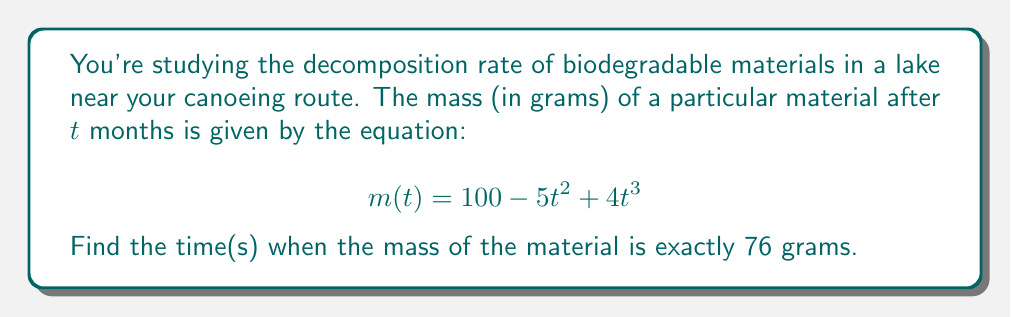Teach me how to tackle this problem. Let's approach this step-by-step:

1) We need to solve the equation:
   $$ 100 - 5t^2 + 4t^3 = 76 $$

2) Subtract 76 from both sides:
   $$ 24 - 5t^2 + 4t^3 = 0 $$

3) Rearrange to standard form:
   $$ 4t^3 - 5t^2 + 24 = 0 $$

4) This is a cubic equation. Let's try to factor it:
   $$ 4t^3 - 5t^2 + 24 = (4t - 3)(t^2 + \frac{3}{4}t - 8) $$

5) Now we can set each factor to zero and solve:

   For $(4t - 3) = 0$:
   $$ t = \frac{3}{4} $$

   For $(t^2 + \frac{3}{4}t - 8) = 0$:
   Use the quadratic formula: $t = \frac{-b \pm \sqrt{b^2 - 4ac}}{2a}$

   $$ t = \frac{-\frac{3}{4} \pm \sqrt{(\frac{3}{4})^2 - 4(1)(-8)}}{2(1)} $$
   $$ t = \frac{-\frac{3}{4} \pm \sqrt{\frac{9}{16} + 32}}{2} $$
   $$ t = \frac{-\frac{3}{4} \pm \sqrt{\frac{521}{16}}}{2} $$
   $$ t = \frac{-\frac{3}{4} \pm \frac{\sqrt{521}}{4}}{2} $$

6) Simplify:
   $$ t = -\frac{3}{8} \pm \frac{\sqrt{521}}{8} $$

7) The positive solution is approximately 2.42, and the negative solution can be discarded as time cannot be negative.

Therefore, the mass of the material will be 76 grams after 0.75 months and approximately 2.42 months.
Answer: $t = \frac{3}{4}$ and $t \approx 2.42$ months 